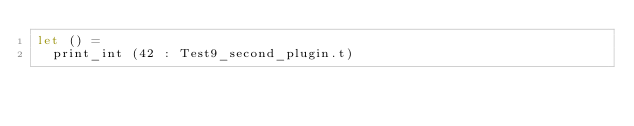Convert code to text. <code><loc_0><loc_0><loc_500><loc_500><_OCaml_>let () =
  print_int (42 : Test9_second_plugin.t)
</code> 